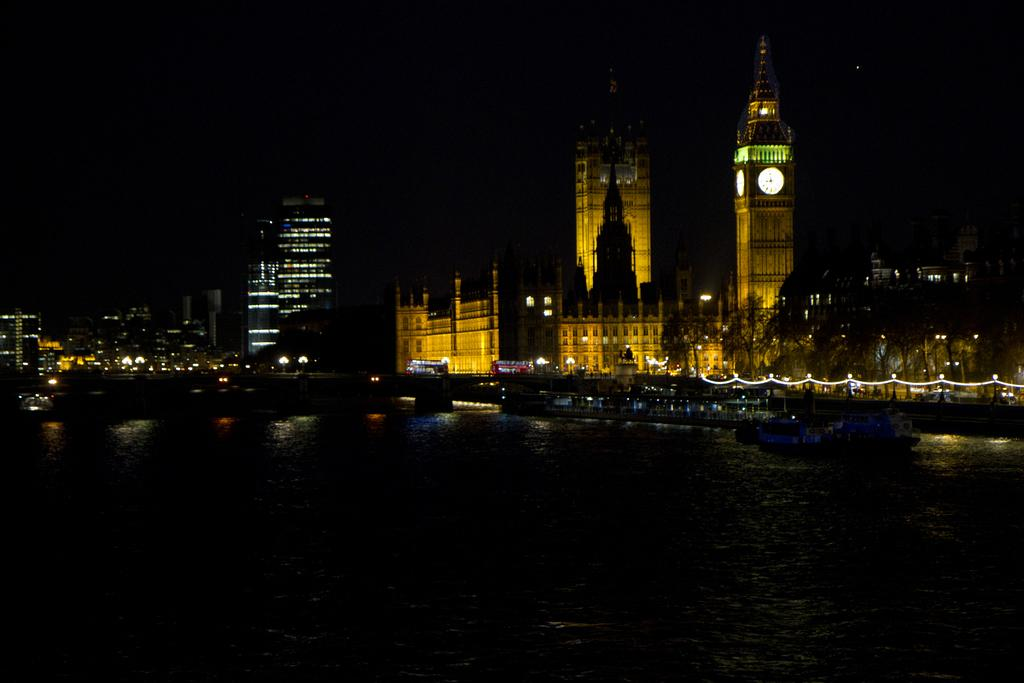What is on the water in the image? There are boats on the water in the image. What can be seen in the distance behind the boats? There are buildings, trees, towers, lights, and vehicles in the background of the image. Can you describe the bridge in the background? There is a bridge in the background of the image. Who is the owner of the robin that can be seen in the image? There is no robin present in the image. What type of government is depicted in the image? The image does not depict any form of government. 